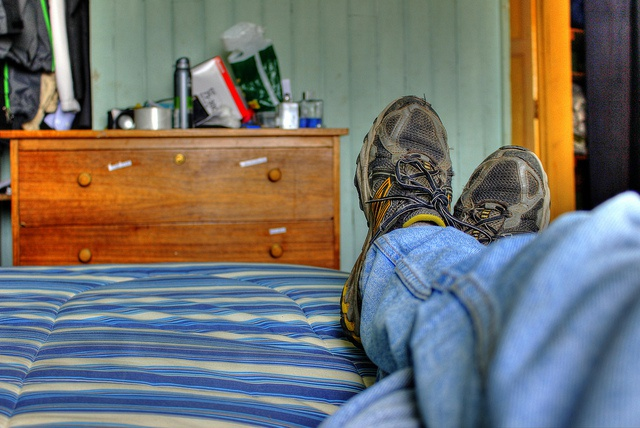Describe the objects in this image and their specific colors. I can see people in gray and darkgray tones and bed in gray, blue, and darkgray tones in this image. 